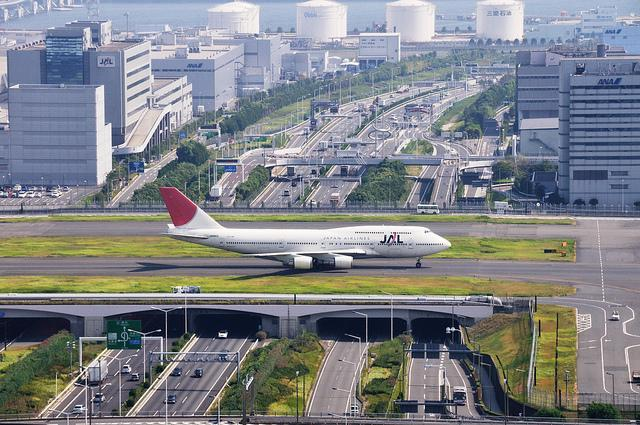What is the large vehicle getting ready to do?

Choices:
A) fire missiles
B) race cars
C) race camels
D) fly fly 